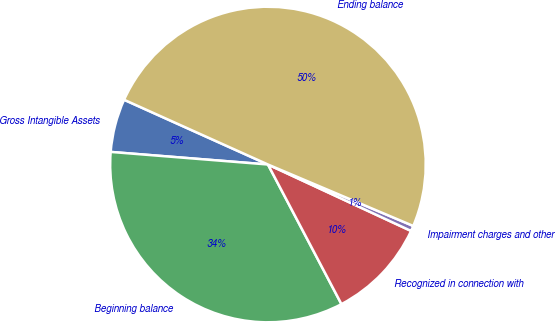Convert chart to OTSL. <chart><loc_0><loc_0><loc_500><loc_500><pie_chart><fcel>Gross Intangible Assets<fcel>Beginning balance<fcel>Recognized in connection with<fcel>Impairment charges and other<fcel>Ending balance<nl><fcel>5.46%<fcel>33.98%<fcel>10.37%<fcel>0.55%<fcel>49.63%<nl></chart> 